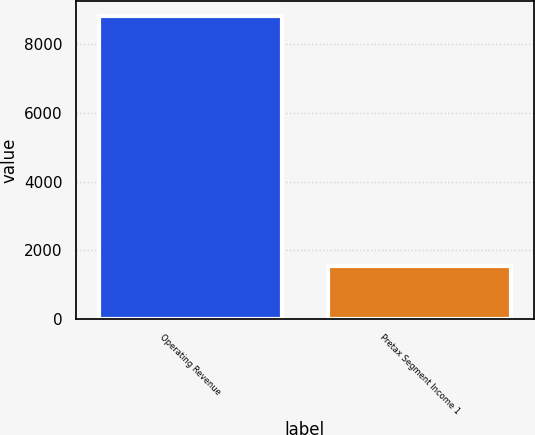<chart> <loc_0><loc_0><loc_500><loc_500><bar_chart><fcel>Operating Revenue<fcel>Pretax Segment Income 1<nl><fcel>8823<fcel>1536<nl></chart> 